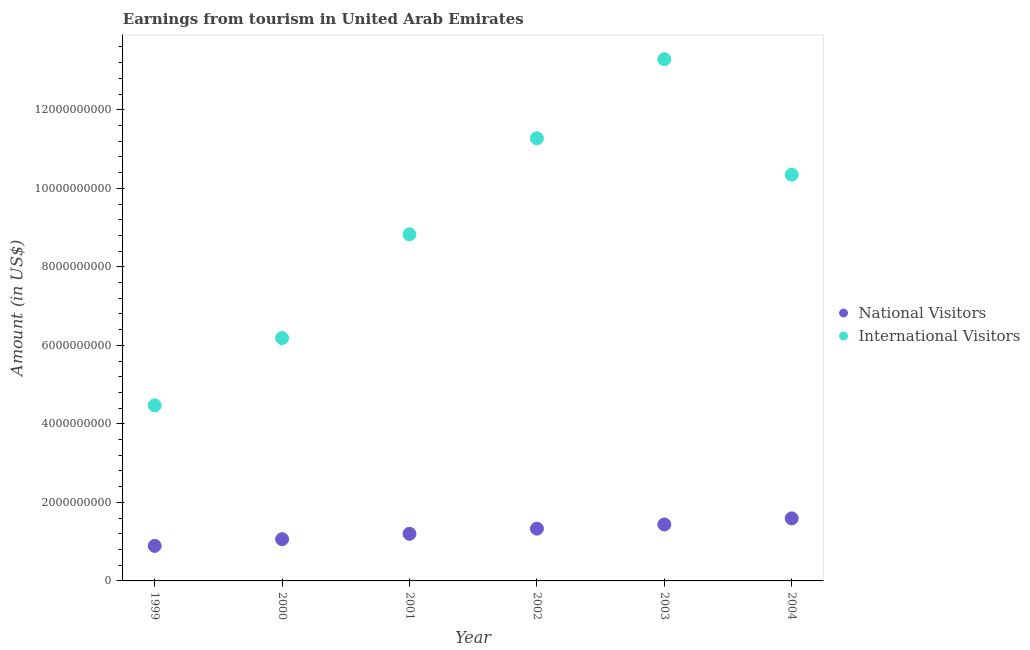What is the amount earned from international visitors in 2004?
Provide a short and direct response. 1.03e+1. Across all years, what is the maximum amount earned from international visitors?
Give a very brief answer. 1.33e+1. Across all years, what is the minimum amount earned from international visitors?
Offer a very short reply. 4.47e+09. What is the total amount earned from international visitors in the graph?
Make the answer very short. 5.44e+1. What is the difference between the amount earned from national visitors in 2000 and that in 2003?
Offer a very short reply. -3.75e+08. What is the difference between the amount earned from international visitors in 2002 and the amount earned from national visitors in 2000?
Keep it short and to the point. 1.02e+1. What is the average amount earned from international visitors per year?
Provide a succinct answer. 9.07e+09. In the year 1999, what is the difference between the amount earned from national visitors and amount earned from international visitors?
Provide a succinct answer. -3.58e+09. In how many years, is the amount earned from national visitors greater than 2800000000 US$?
Provide a succinct answer. 0. What is the ratio of the amount earned from national visitors in 2001 to that in 2002?
Offer a terse response. 0.9. Is the difference between the amount earned from national visitors in 2000 and 2004 greater than the difference between the amount earned from international visitors in 2000 and 2004?
Provide a short and direct response. Yes. What is the difference between the highest and the second highest amount earned from national visitors?
Your answer should be very brief. 1.55e+08. What is the difference between the highest and the lowest amount earned from national visitors?
Give a very brief answer. 7.00e+08. In how many years, is the amount earned from national visitors greater than the average amount earned from national visitors taken over all years?
Ensure brevity in your answer.  3. Is the sum of the amount earned from national visitors in 2000 and 2003 greater than the maximum amount earned from international visitors across all years?
Provide a short and direct response. No. Does the amount earned from national visitors monotonically increase over the years?
Provide a succinct answer. Yes. Is the amount earned from international visitors strictly greater than the amount earned from national visitors over the years?
Your answer should be very brief. Yes. How many dotlines are there?
Offer a very short reply. 2. How many years are there in the graph?
Ensure brevity in your answer.  6. What is the difference between two consecutive major ticks on the Y-axis?
Your response must be concise. 2.00e+09. Are the values on the major ticks of Y-axis written in scientific E-notation?
Offer a very short reply. No. Does the graph contain any zero values?
Provide a succinct answer. No. Does the graph contain grids?
Make the answer very short. No. Where does the legend appear in the graph?
Provide a succinct answer. Center right. How many legend labels are there?
Provide a short and direct response. 2. How are the legend labels stacked?
Offer a very short reply. Vertical. What is the title of the graph?
Provide a succinct answer. Earnings from tourism in United Arab Emirates. What is the label or title of the Y-axis?
Give a very brief answer. Amount (in US$). What is the Amount (in US$) in National Visitors in 1999?
Give a very brief answer. 8.93e+08. What is the Amount (in US$) of International Visitors in 1999?
Your answer should be compact. 4.47e+09. What is the Amount (in US$) in National Visitors in 2000?
Provide a succinct answer. 1.06e+09. What is the Amount (in US$) in International Visitors in 2000?
Give a very brief answer. 6.19e+09. What is the Amount (in US$) of National Visitors in 2001?
Your answer should be compact. 1.20e+09. What is the Amount (in US$) in International Visitors in 2001?
Offer a terse response. 8.83e+09. What is the Amount (in US$) of National Visitors in 2002?
Ensure brevity in your answer.  1.33e+09. What is the Amount (in US$) in International Visitors in 2002?
Make the answer very short. 1.13e+1. What is the Amount (in US$) of National Visitors in 2003?
Your response must be concise. 1.44e+09. What is the Amount (in US$) of International Visitors in 2003?
Give a very brief answer. 1.33e+1. What is the Amount (in US$) of National Visitors in 2004?
Your answer should be very brief. 1.59e+09. What is the Amount (in US$) of International Visitors in 2004?
Give a very brief answer. 1.03e+1. Across all years, what is the maximum Amount (in US$) of National Visitors?
Your response must be concise. 1.59e+09. Across all years, what is the maximum Amount (in US$) in International Visitors?
Ensure brevity in your answer.  1.33e+1. Across all years, what is the minimum Amount (in US$) of National Visitors?
Make the answer very short. 8.93e+08. Across all years, what is the minimum Amount (in US$) of International Visitors?
Keep it short and to the point. 4.47e+09. What is the total Amount (in US$) in National Visitors in the graph?
Give a very brief answer. 7.52e+09. What is the total Amount (in US$) in International Visitors in the graph?
Keep it short and to the point. 5.44e+1. What is the difference between the Amount (in US$) in National Visitors in 1999 and that in 2000?
Keep it short and to the point. -1.70e+08. What is the difference between the Amount (in US$) of International Visitors in 1999 and that in 2000?
Ensure brevity in your answer.  -1.71e+09. What is the difference between the Amount (in US$) in National Visitors in 1999 and that in 2001?
Give a very brief answer. -3.07e+08. What is the difference between the Amount (in US$) in International Visitors in 1999 and that in 2001?
Your answer should be compact. -4.36e+09. What is the difference between the Amount (in US$) in National Visitors in 1999 and that in 2002?
Offer a very short reply. -4.39e+08. What is the difference between the Amount (in US$) of International Visitors in 1999 and that in 2002?
Provide a succinct answer. -6.80e+09. What is the difference between the Amount (in US$) of National Visitors in 1999 and that in 2003?
Your response must be concise. -5.45e+08. What is the difference between the Amount (in US$) in International Visitors in 1999 and that in 2003?
Offer a very short reply. -8.82e+09. What is the difference between the Amount (in US$) of National Visitors in 1999 and that in 2004?
Your answer should be very brief. -7.00e+08. What is the difference between the Amount (in US$) of International Visitors in 1999 and that in 2004?
Offer a terse response. -5.88e+09. What is the difference between the Amount (in US$) of National Visitors in 2000 and that in 2001?
Your answer should be very brief. -1.37e+08. What is the difference between the Amount (in US$) of International Visitors in 2000 and that in 2001?
Offer a very short reply. -2.64e+09. What is the difference between the Amount (in US$) in National Visitors in 2000 and that in 2002?
Provide a succinct answer. -2.69e+08. What is the difference between the Amount (in US$) in International Visitors in 2000 and that in 2002?
Your answer should be very brief. -5.09e+09. What is the difference between the Amount (in US$) of National Visitors in 2000 and that in 2003?
Offer a very short reply. -3.75e+08. What is the difference between the Amount (in US$) in International Visitors in 2000 and that in 2003?
Your answer should be compact. -7.10e+09. What is the difference between the Amount (in US$) in National Visitors in 2000 and that in 2004?
Provide a short and direct response. -5.30e+08. What is the difference between the Amount (in US$) of International Visitors in 2000 and that in 2004?
Your answer should be very brief. -4.16e+09. What is the difference between the Amount (in US$) in National Visitors in 2001 and that in 2002?
Your response must be concise. -1.32e+08. What is the difference between the Amount (in US$) of International Visitors in 2001 and that in 2002?
Keep it short and to the point. -2.45e+09. What is the difference between the Amount (in US$) of National Visitors in 2001 and that in 2003?
Your answer should be very brief. -2.38e+08. What is the difference between the Amount (in US$) of International Visitors in 2001 and that in 2003?
Your response must be concise. -4.46e+09. What is the difference between the Amount (in US$) of National Visitors in 2001 and that in 2004?
Make the answer very short. -3.93e+08. What is the difference between the Amount (in US$) in International Visitors in 2001 and that in 2004?
Keep it short and to the point. -1.52e+09. What is the difference between the Amount (in US$) in National Visitors in 2002 and that in 2003?
Provide a short and direct response. -1.06e+08. What is the difference between the Amount (in US$) of International Visitors in 2002 and that in 2003?
Provide a succinct answer. -2.02e+09. What is the difference between the Amount (in US$) in National Visitors in 2002 and that in 2004?
Ensure brevity in your answer.  -2.61e+08. What is the difference between the Amount (in US$) in International Visitors in 2002 and that in 2004?
Offer a very short reply. 9.26e+08. What is the difference between the Amount (in US$) in National Visitors in 2003 and that in 2004?
Give a very brief answer. -1.55e+08. What is the difference between the Amount (in US$) of International Visitors in 2003 and that in 2004?
Ensure brevity in your answer.  2.94e+09. What is the difference between the Amount (in US$) of National Visitors in 1999 and the Amount (in US$) of International Visitors in 2000?
Ensure brevity in your answer.  -5.29e+09. What is the difference between the Amount (in US$) of National Visitors in 1999 and the Amount (in US$) of International Visitors in 2001?
Keep it short and to the point. -7.93e+09. What is the difference between the Amount (in US$) in National Visitors in 1999 and the Amount (in US$) in International Visitors in 2002?
Make the answer very short. -1.04e+1. What is the difference between the Amount (in US$) of National Visitors in 1999 and the Amount (in US$) of International Visitors in 2003?
Provide a succinct answer. -1.24e+1. What is the difference between the Amount (in US$) in National Visitors in 1999 and the Amount (in US$) in International Visitors in 2004?
Your answer should be compact. -9.45e+09. What is the difference between the Amount (in US$) of National Visitors in 2000 and the Amount (in US$) of International Visitors in 2001?
Keep it short and to the point. -7.76e+09. What is the difference between the Amount (in US$) of National Visitors in 2000 and the Amount (in US$) of International Visitors in 2002?
Your answer should be compact. -1.02e+1. What is the difference between the Amount (in US$) of National Visitors in 2000 and the Amount (in US$) of International Visitors in 2003?
Keep it short and to the point. -1.22e+1. What is the difference between the Amount (in US$) in National Visitors in 2000 and the Amount (in US$) in International Visitors in 2004?
Give a very brief answer. -9.28e+09. What is the difference between the Amount (in US$) in National Visitors in 2001 and the Amount (in US$) in International Visitors in 2002?
Keep it short and to the point. -1.01e+1. What is the difference between the Amount (in US$) in National Visitors in 2001 and the Amount (in US$) in International Visitors in 2003?
Offer a very short reply. -1.21e+1. What is the difference between the Amount (in US$) in National Visitors in 2001 and the Amount (in US$) in International Visitors in 2004?
Your response must be concise. -9.15e+09. What is the difference between the Amount (in US$) in National Visitors in 2002 and the Amount (in US$) in International Visitors in 2003?
Offer a terse response. -1.20e+1. What is the difference between the Amount (in US$) in National Visitors in 2002 and the Amount (in US$) in International Visitors in 2004?
Provide a succinct answer. -9.02e+09. What is the difference between the Amount (in US$) of National Visitors in 2003 and the Amount (in US$) of International Visitors in 2004?
Keep it short and to the point. -8.91e+09. What is the average Amount (in US$) of National Visitors per year?
Your response must be concise. 1.25e+09. What is the average Amount (in US$) of International Visitors per year?
Offer a very short reply. 9.07e+09. In the year 1999, what is the difference between the Amount (in US$) in National Visitors and Amount (in US$) in International Visitors?
Offer a terse response. -3.58e+09. In the year 2000, what is the difference between the Amount (in US$) in National Visitors and Amount (in US$) in International Visitors?
Your response must be concise. -5.12e+09. In the year 2001, what is the difference between the Amount (in US$) of National Visitors and Amount (in US$) of International Visitors?
Offer a terse response. -7.63e+09. In the year 2002, what is the difference between the Amount (in US$) of National Visitors and Amount (in US$) of International Visitors?
Offer a terse response. -9.94e+09. In the year 2003, what is the difference between the Amount (in US$) in National Visitors and Amount (in US$) in International Visitors?
Make the answer very short. -1.18e+1. In the year 2004, what is the difference between the Amount (in US$) in National Visitors and Amount (in US$) in International Visitors?
Your answer should be very brief. -8.75e+09. What is the ratio of the Amount (in US$) of National Visitors in 1999 to that in 2000?
Provide a succinct answer. 0.84. What is the ratio of the Amount (in US$) in International Visitors in 1999 to that in 2000?
Your response must be concise. 0.72. What is the ratio of the Amount (in US$) in National Visitors in 1999 to that in 2001?
Provide a succinct answer. 0.74. What is the ratio of the Amount (in US$) of International Visitors in 1999 to that in 2001?
Provide a succinct answer. 0.51. What is the ratio of the Amount (in US$) in National Visitors in 1999 to that in 2002?
Ensure brevity in your answer.  0.67. What is the ratio of the Amount (in US$) in International Visitors in 1999 to that in 2002?
Provide a succinct answer. 0.4. What is the ratio of the Amount (in US$) of National Visitors in 1999 to that in 2003?
Your answer should be compact. 0.62. What is the ratio of the Amount (in US$) in International Visitors in 1999 to that in 2003?
Your answer should be very brief. 0.34. What is the ratio of the Amount (in US$) in National Visitors in 1999 to that in 2004?
Your response must be concise. 0.56. What is the ratio of the Amount (in US$) of International Visitors in 1999 to that in 2004?
Your response must be concise. 0.43. What is the ratio of the Amount (in US$) of National Visitors in 2000 to that in 2001?
Provide a succinct answer. 0.89. What is the ratio of the Amount (in US$) of International Visitors in 2000 to that in 2001?
Offer a terse response. 0.7. What is the ratio of the Amount (in US$) of National Visitors in 2000 to that in 2002?
Your answer should be very brief. 0.8. What is the ratio of the Amount (in US$) of International Visitors in 2000 to that in 2002?
Make the answer very short. 0.55. What is the ratio of the Amount (in US$) in National Visitors in 2000 to that in 2003?
Provide a short and direct response. 0.74. What is the ratio of the Amount (in US$) of International Visitors in 2000 to that in 2003?
Give a very brief answer. 0.47. What is the ratio of the Amount (in US$) of National Visitors in 2000 to that in 2004?
Your answer should be very brief. 0.67. What is the ratio of the Amount (in US$) of International Visitors in 2000 to that in 2004?
Make the answer very short. 0.6. What is the ratio of the Amount (in US$) in National Visitors in 2001 to that in 2002?
Your answer should be very brief. 0.9. What is the ratio of the Amount (in US$) of International Visitors in 2001 to that in 2002?
Offer a very short reply. 0.78. What is the ratio of the Amount (in US$) in National Visitors in 2001 to that in 2003?
Provide a short and direct response. 0.83. What is the ratio of the Amount (in US$) of International Visitors in 2001 to that in 2003?
Keep it short and to the point. 0.66. What is the ratio of the Amount (in US$) of National Visitors in 2001 to that in 2004?
Your response must be concise. 0.75. What is the ratio of the Amount (in US$) of International Visitors in 2001 to that in 2004?
Offer a very short reply. 0.85. What is the ratio of the Amount (in US$) in National Visitors in 2002 to that in 2003?
Offer a terse response. 0.93. What is the ratio of the Amount (in US$) of International Visitors in 2002 to that in 2003?
Your answer should be compact. 0.85. What is the ratio of the Amount (in US$) in National Visitors in 2002 to that in 2004?
Offer a terse response. 0.84. What is the ratio of the Amount (in US$) of International Visitors in 2002 to that in 2004?
Provide a succinct answer. 1.09. What is the ratio of the Amount (in US$) of National Visitors in 2003 to that in 2004?
Provide a succinct answer. 0.9. What is the ratio of the Amount (in US$) in International Visitors in 2003 to that in 2004?
Provide a short and direct response. 1.28. What is the difference between the highest and the second highest Amount (in US$) in National Visitors?
Provide a short and direct response. 1.55e+08. What is the difference between the highest and the second highest Amount (in US$) in International Visitors?
Your response must be concise. 2.02e+09. What is the difference between the highest and the lowest Amount (in US$) in National Visitors?
Your response must be concise. 7.00e+08. What is the difference between the highest and the lowest Amount (in US$) of International Visitors?
Offer a very short reply. 8.82e+09. 